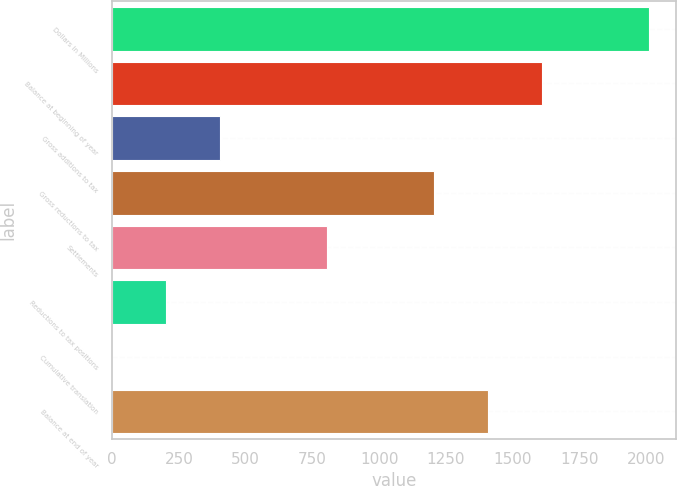Convert chart. <chart><loc_0><loc_0><loc_500><loc_500><bar_chart><fcel>Dollars in Millions<fcel>Balance at beginning of year<fcel>Gross additions to tax<fcel>Gross reductions to tax<fcel>Settlements<fcel>Reductions to tax positions<fcel>Cumulative translation<fcel>Balance at end of year<nl><fcel>2010<fcel>1608.2<fcel>402.8<fcel>1206.4<fcel>804.6<fcel>201.9<fcel>1<fcel>1407.3<nl></chart> 